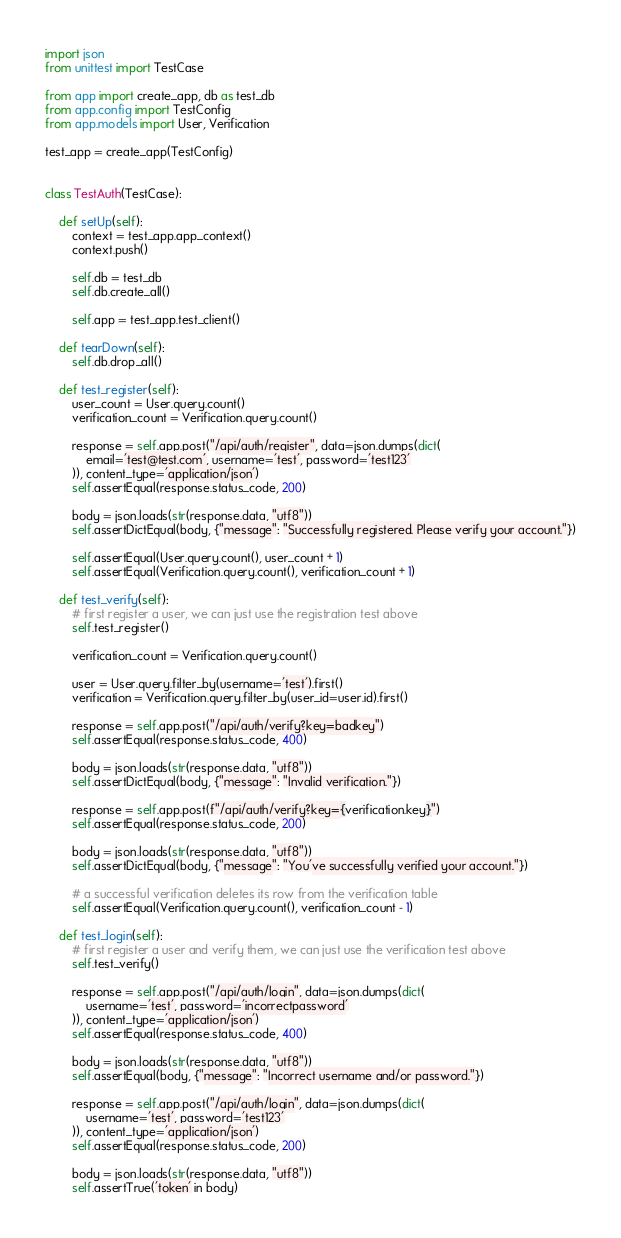Convert code to text. <code><loc_0><loc_0><loc_500><loc_500><_Python_>import json
from unittest import TestCase

from app import create_app, db as test_db
from app.config import TestConfig
from app.models import User, Verification

test_app = create_app(TestConfig)


class TestAuth(TestCase):

    def setUp(self):
        context = test_app.app_context()
        context.push()

        self.db = test_db
        self.db.create_all()

        self.app = test_app.test_client()

    def tearDown(self):
        self.db.drop_all()

    def test_register(self):
        user_count = User.query.count()
        verification_count = Verification.query.count()

        response = self.app.post("/api/auth/register", data=json.dumps(dict(
            email='test@test.com', username='test', password='test123'
        )), content_type='application/json')
        self.assertEqual(response.status_code, 200)

        body = json.loads(str(response.data, "utf8"))
        self.assertDictEqual(body, {"message": "Successfully registered. Please verify your account."})

        self.assertEqual(User.query.count(), user_count + 1)
        self.assertEqual(Verification.query.count(), verification_count + 1)

    def test_verify(self):
        # first register a user, we can just use the registration test above
        self.test_register()

        verification_count = Verification.query.count()

        user = User.query.filter_by(username='test').first()
        verification = Verification.query.filter_by(user_id=user.id).first()

        response = self.app.post("/api/auth/verify?key=badkey")
        self.assertEqual(response.status_code, 400)

        body = json.loads(str(response.data, "utf8"))
        self.assertDictEqual(body, {"message": "Invalid verification."})

        response = self.app.post(f"/api/auth/verify?key={verification.key}")
        self.assertEqual(response.status_code, 200)

        body = json.loads(str(response.data, "utf8"))
        self.assertDictEqual(body, {"message": "You've successfully verified your account."})

        # a successful verification deletes its row from the verification table
        self.assertEqual(Verification.query.count(), verification_count - 1)

    def test_login(self):
        # first register a user and verify them, we can just use the verification test above
        self.test_verify()

        response = self.app.post("/api/auth/login", data=json.dumps(dict(
            username='test', password='incorrectpassword'
        )), content_type='application/json')
        self.assertEqual(response.status_code, 400)

        body = json.loads(str(response.data, "utf8"))
        self.assertEqual(body, {"message": "Incorrect username and/or password."})

        response = self.app.post("/api/auth/login", data=json.dumps(dict(
            username='test', password='test123'
        )), content_type='application/json')
        self.assertEqual(response.status_code, 200)

        body = json.loads(str(response.data, "utf8"))
        self.assertTrue('token' in body)
</code> 